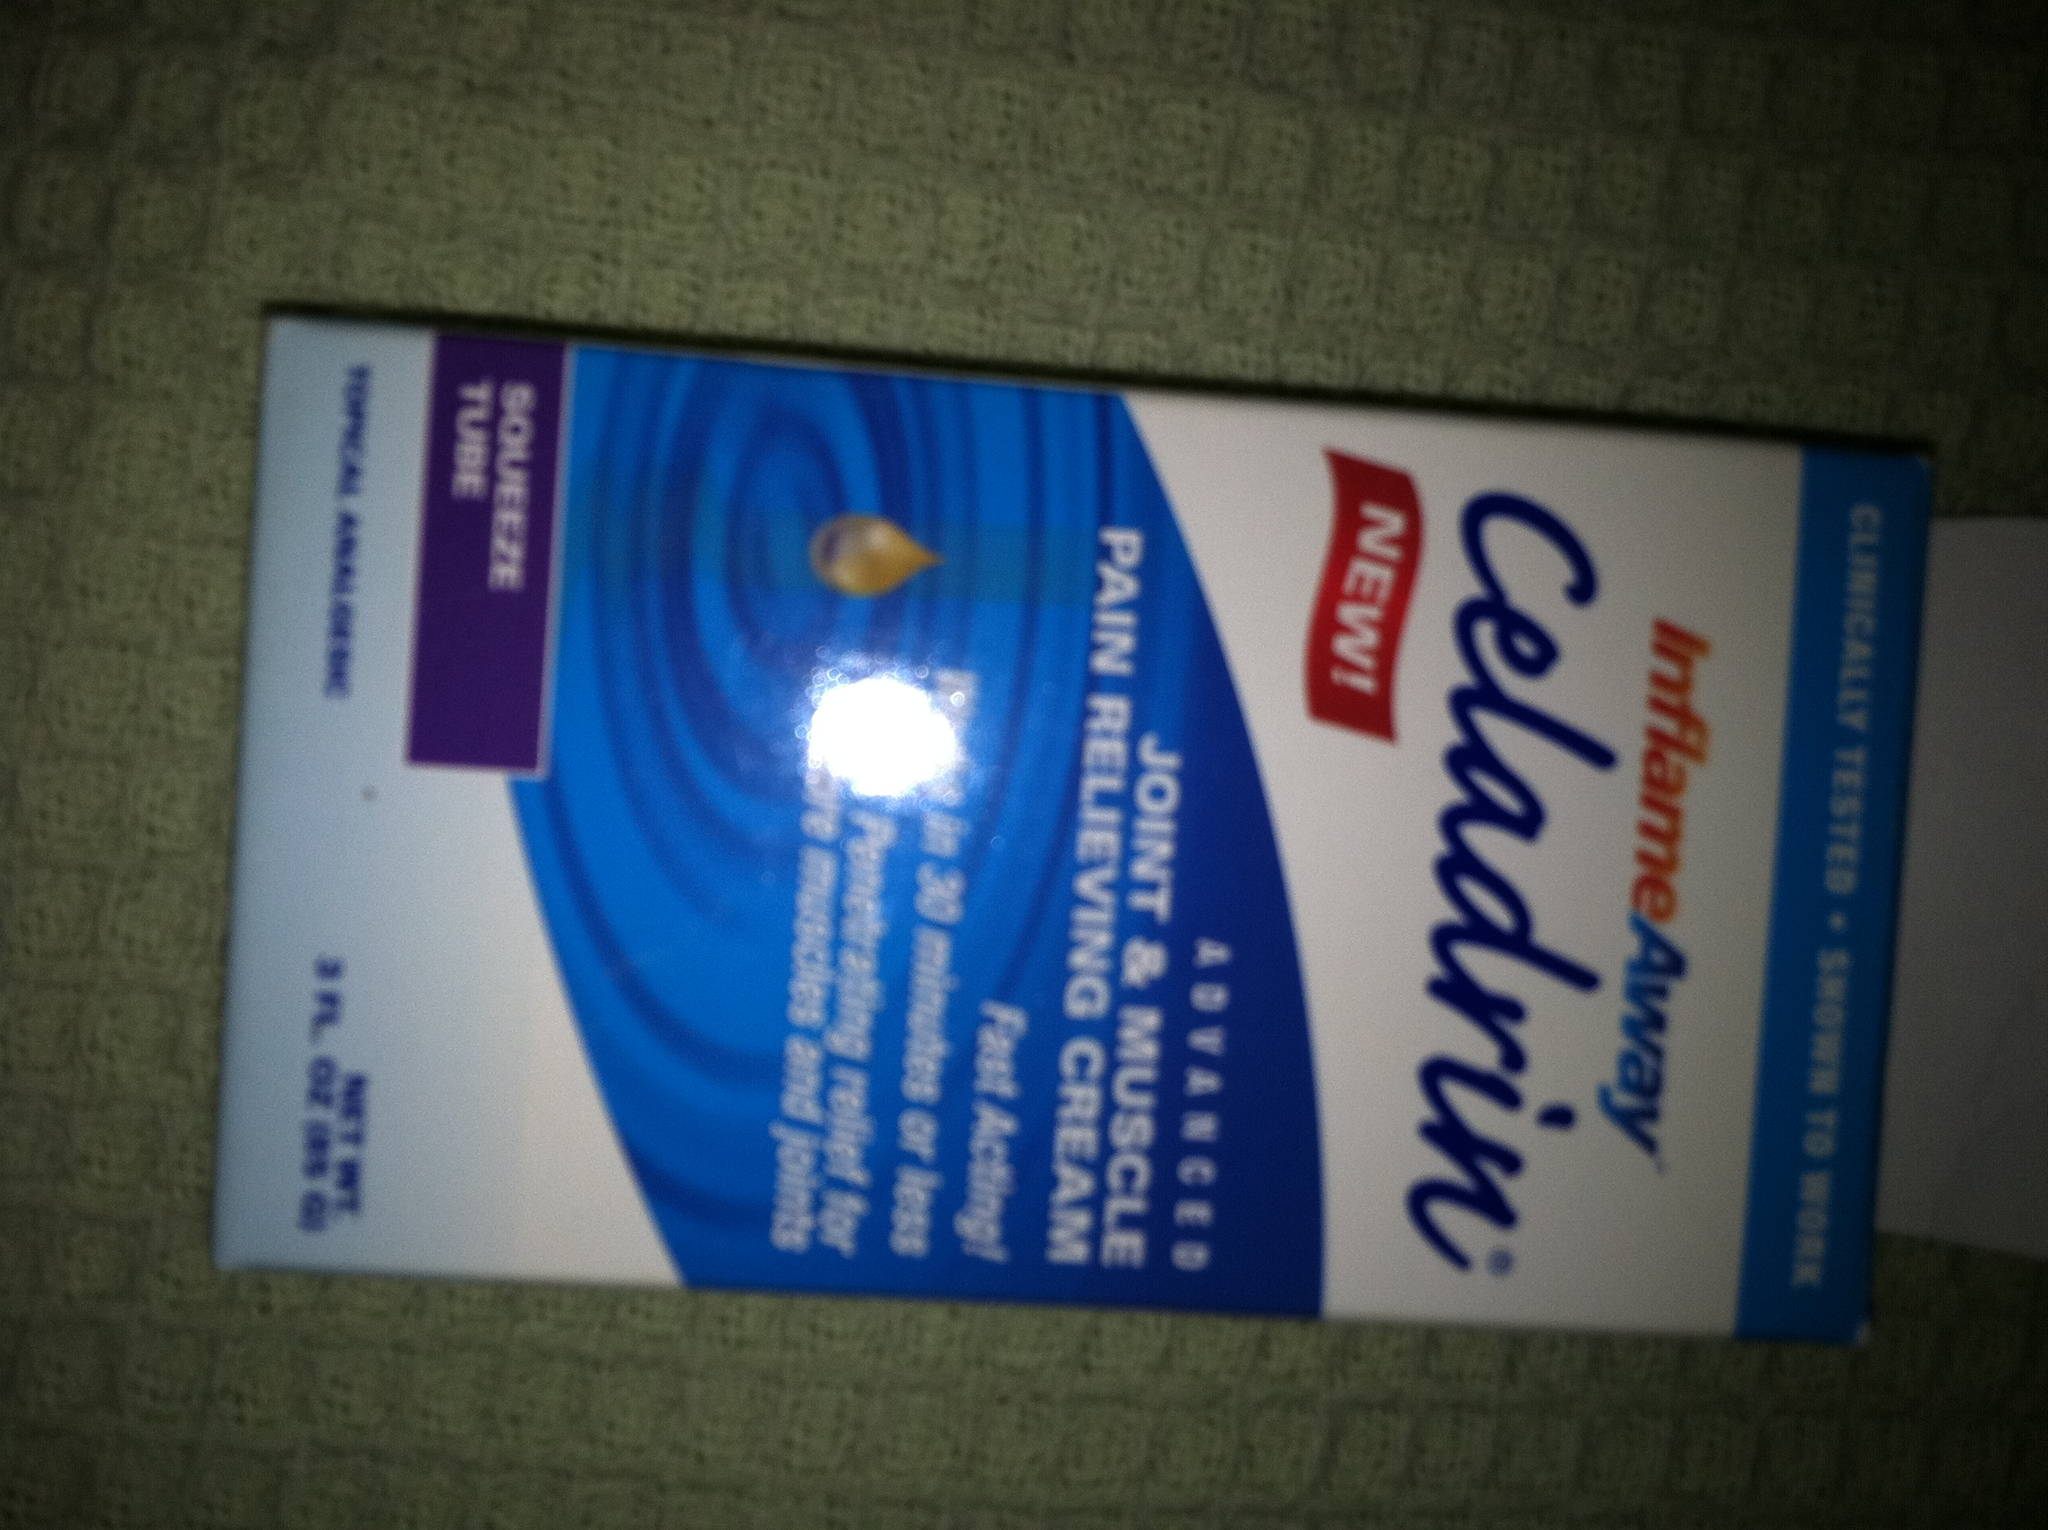what is this product? This product is 'Capzasin,' a topical pain relieving cream designed for quick relief of muscle aches and joint pain. It uses capsaicin as its active ingredient to provide a warming sensation that helps to alleviate discomfort. 